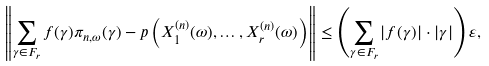<formula> <loc_0><loc_0><loc_500><loc_500>\left \| \sum _ { \gamma \in F _ { r } } f ( \gamma ) \pi _ { n , \omega } ( \gamma ) - p \left ( X _ { 1 } ^ { ( n ) } ( \omega ) , \dots , X _ { r } ^ { ( n ) } ( \omega ) \right ) \right \| \leq \left ( \sum _ { \gamma \in F _ { r } } | f ( \gamma ) | \cdot | \gamma | \right ) \varepsilon ,</formula> 